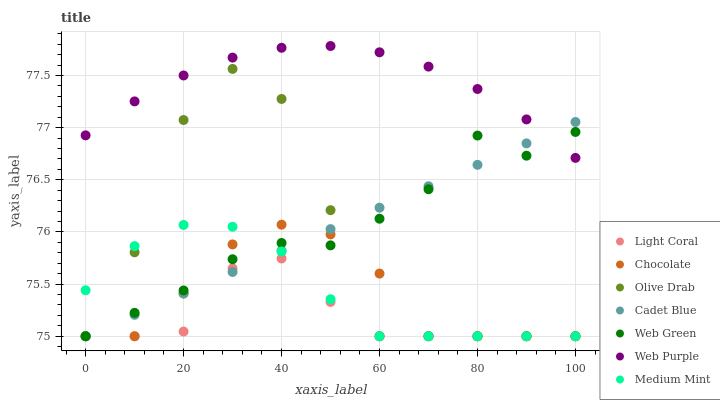Does Light Coral have the minimum area under the curve?
Answer yes or no. Yes. Does Web Purple have the maximum area under the curve?
Answer yes or no. Yes. Does Cadet Blue have the minimum area under the curve?
Answer yes or no. No. Does Cadet Blue have the maximum area under the curve?
Answer yes or no. No. Is Cadet Blue the smoothest?
Answer yes or no. Yes. Is Olive Drab the roughest?
Answer yes or no. Yes. Is Web Green the smoothest?
Answer yes or no. No. Is Web Green the roughest?
Answer yes or no. No. Does Medium Mint have the lowest value?
Answer yes or no. Yes. Does Web Purple have the lowest value?
Answer yes or no. No. Does Web Purple have the highest value?
Answer yes or no. Yes. Does Cadet Blue have the highest value?
Answer yes or no. No. Is Chocolate less than Web Purple?
Answer yes or no. Yes. Is Web Purple greater than Medium Mint?
Answer yes or no. Yes. Does Web Green intersect Medium Mint?
Answer yes or no. Yes. Is Web Green less than Medium Mint?
Answer yes or no. No. Is Web Green greater than Medium Mint?
Answer yes or no. No. Does Chocolate intersect Web Purple?
Answer yes or no. No. 